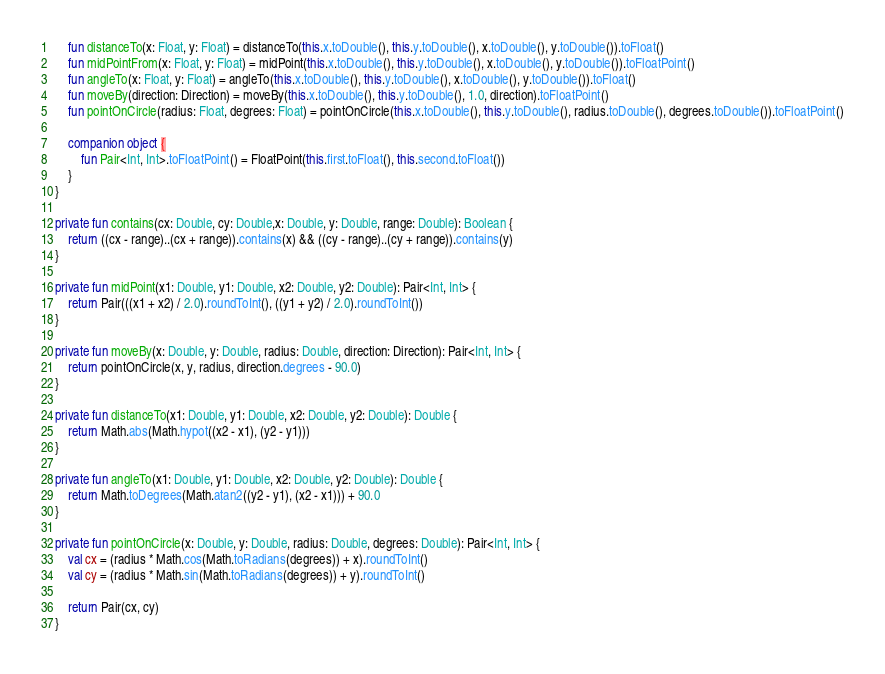<code> <loc_0><loc_0><loc_500><loc_500><_Kotlin_>    fun distanceTo(x: Float, y: Float) = distanceTo(this.x.toDouble(), this.y.toDouble(), x.toDouble(), y.toDouble()).toFloat()
    fun midPointFrom(x: Float, y: Float) = midPoint(this.x.toDouble(), this.y.toDouble(), x.toDouble(), y.toDouble()).toFloatPoint()
    fun angleTo(x: Float, y: Float) = angleTo(this.x.toDouble(), this.y.toDouble(), x.toDouble(), y.toDouble()).toFloat()
    fun moveBy(direction: Direction) = moveBy(this.x.toDouble(), this.y.toDouble(), 1.0, direction).toFloatPoint()
    fun pointOnCircle(radius: Float, degrees: Float) = pointOnCircle(this.x.toDouble(), this.y.toDouble(), radius.toDouble(), degrees.toDouble()).toFloatPoint()

    companion object {
        fun Pair<Int, Int>.toFloatPoint() = FloatPoint(this.first.toFloat(), this.second.toFloat())
    }
}

private fun contains(cx: Double, cy: Double,x: Double, y: Double, range: Double): Boolean {
    return ((cx - range)..(cx + range)).contains(x) && ((cy - range)..(cy + range)).contains(y)
}

private fun midPoint(x1: Double, y1: Double, x2: Double, y2: Double): Pair<Int, Int> {
    return Pair(((x1 + x2) / 2.0).roundToInt(), ((y1 + y2) / 2.0).roundToInt())
}

private fun moveBy(x: Double, y: Double, radius: Double, direction: Direction): Pair<Int, Int> {
    return pointOnCircle(x, y, radius, direction.degrees - 90.0)
}

private fun distanceTo(x1: Double, y1: Double, x2: Double, y2: Double): Double {
    return Math.abs(Math.hypot((x2 - x1), (y2 - y1)))
}

private fun angleTo(x1: Double, y1: Double, x2: Double, y2: Double): Double {
    return Math.toDegrees(Math.atan2((y2 - y1), (x2 - x1))) + 90.0
}

private fun pointOnCircle(x: Double, y: Double, radius: Double, degrees: Double): Pair<Int, Int> {
    val cx = (radius * Math.cos(Math.toRadians(degrees)) + x).roundToInt()
    val cy = (radius * Math.sin(Math.toRadians(degrees)) + y).roundToInt()

    return Pair(cx, cy)
}
</code> 